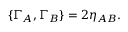Convert formula to latex. <formula><loc_0><loc_0><loc_500><loc_500>{ \{ \Gamma _ { A } , \Gamma _ { B } \} = 2 \eta _ { A B } . }</formula> 